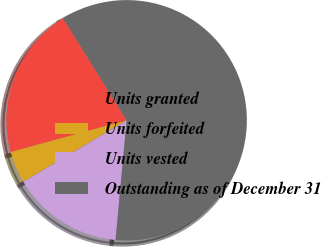Convert chart to OTSL. <chart><loc_0><loc_0><loc_500><loc_500><pie_chart><fcel>Units granted<fcel>Units forfeited<fcel>Units vested<fcel>Outstanding as of December 31<nl><fcel>20.38%<fcel>4.28%<fcel>14.99%<fcel>60.35%<nl></chart> 